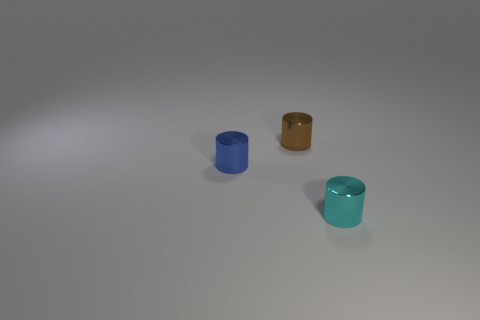Add 1 small brown cylinders. How many objects exist? 4 Add 3 brown blocks. How many brown blocks exist? 3 Subtract 0 yellow cylinders. How many objects are left? 3 Subtract all small cyan cylinders. Subtract all red shiny blocks. How many objects are left? 2 Add 2 blue things. How many blue things are left? 3 